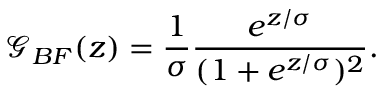<formula> <loc_0><loc_0><loc_500><loc_500>\mathcal { G } _ { B F } ( z ) = \frac { 1 } { \sigma } \frac { e ^ { z / \sigma } } { ( 1 + e ^ { z / \sigma } ) ^ { 2 } } .</formula> 